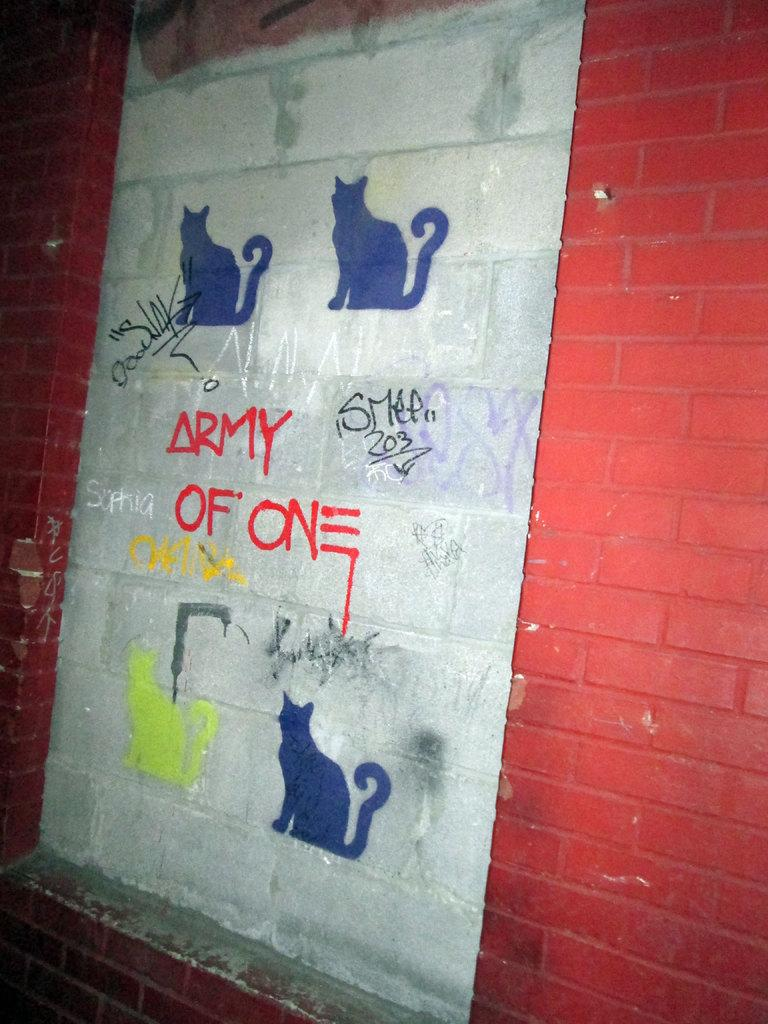What is depicted in the painting on the wall? There is a painting of cats on a wall. What else can be seen on the wall besides the painting? There is text written on the wall. What color paint is used on either side of the painting? There is red paint on either side of the painting. What type of action is the head of the cat performing in the painting? There is no specific action being performed by the head of the cat in the painting, as it is a static image. 